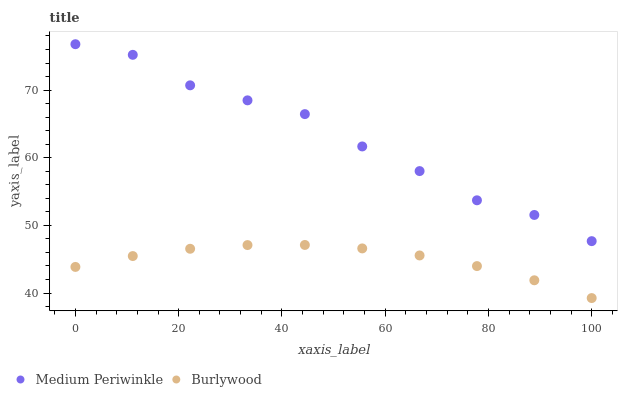Does Burlywood have the minimum area under the curve?
Answer yes or no. Yes. Does Medium Periwinkle have the maximum area under the curve?
Answer yes or no. Yes. Does Medium Periwinkle have the minimum area under the curve?
Answer yes or no. No. Is Burlywood the smoothest?
Answer yes or no. Yes. Is Medium Periwinkle the roughest?
Answer yes or no. Yes. Is Medium Periwinkle the smoothest?
Answer yes or no. No. Does Burlywood have the lowest value?
Answer yes or no. Yes. Does Medium Periwinkle have the lowest value?
Answer yes or no. No. Does Medium Periwinkle have the highest value?
Answer yes or no. Yes. Is Burlywood less than Medium Periwinkle?
Answer yes or no. Yes. Is Medium Periwinkle greater than Burlywood?
Answer yes or no. Yes. Does Burlywood intersect Medium Periwinkle?
Answer yes or no. No. 